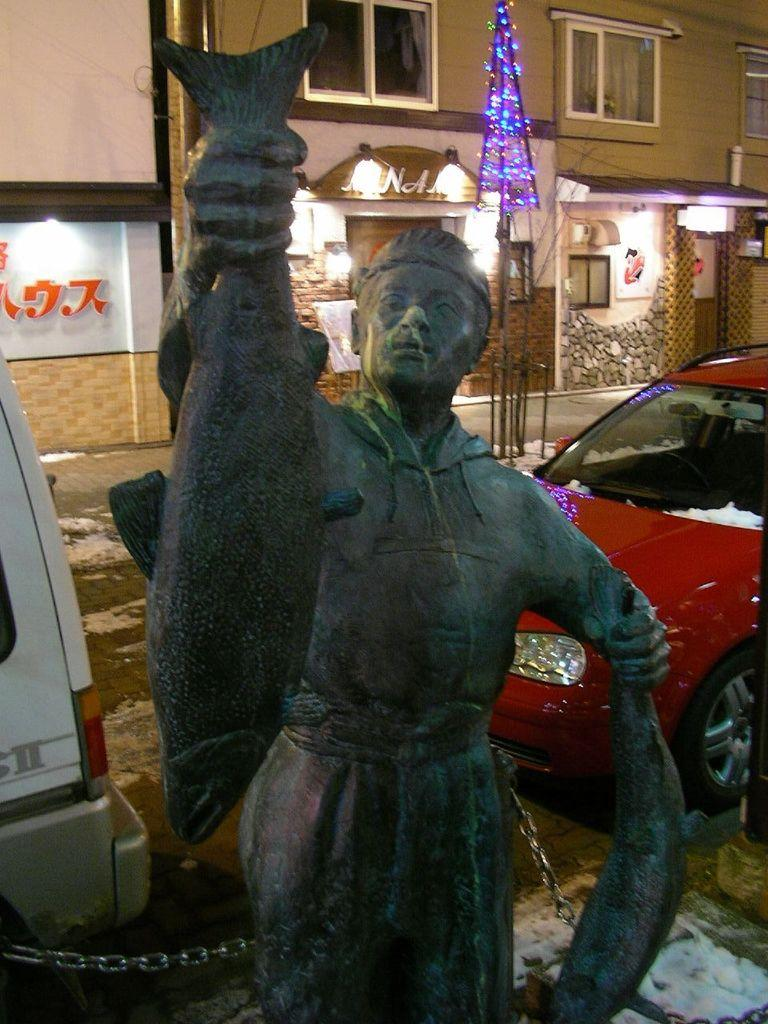What is the main subject of the image? There is a sculpture in the image. What else can be seen in the image besides the sculpture? There are cars, boards, windows, lights, and a building in the image. Can you describe the building in the image? There is a building in the image, but no specific details are provided about its appearance or features. What type of lights are present in the image? There are lights in the image, but no specific details are provided about their type or function. What is the purpose of the self in the image? There is no self present in the image; it features a sculpture, cars, boards, windows, lights, and a building. 